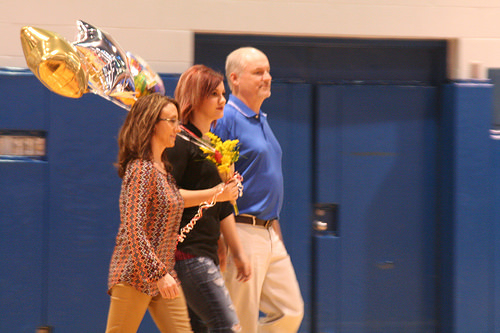<image>
Is the woman under the balloon? Yes. The woman is positioned underneath the balloon, with the balloon above it in the vertical space. 